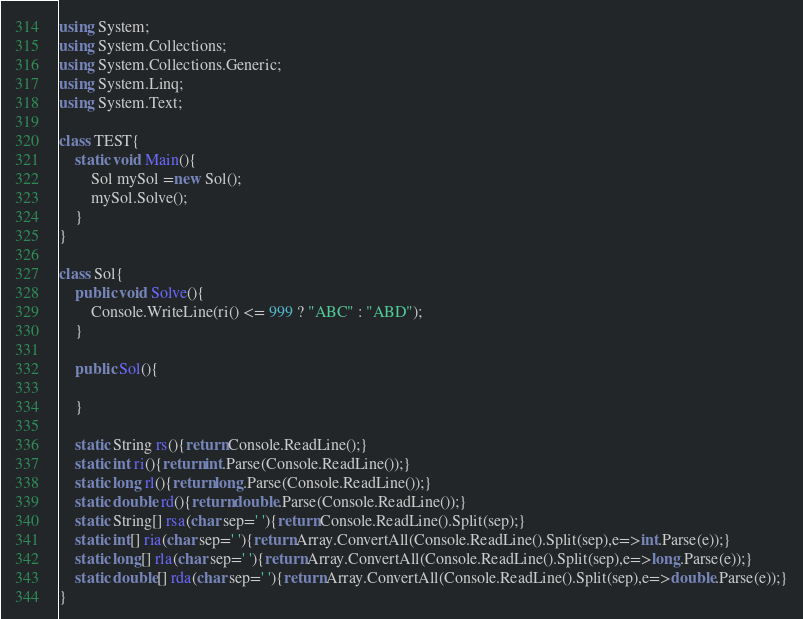Convert code to text. <code><loc_0><loc_0><loc_500><loc_500><_C#_>using System;
using System.Collections;
using System.Collections.Generic;
using System.Linq;
using System.Text;

class TEST{
	static void Main(){
		Sol mySol =new Sol();
		mySol.Solve();
	}
}

class Sol{
	public void Solve(){
		Console.WriteLine(ri() <= 999 ? "ABC" : "ABD");
	}

	public Sol(){
		
	}

	static String rs(){return Console.ReadLine();}
	static int ri(){return int.Parse(Console.ReadLine());}
	static long rl(){return long.Parse(Console.ReadLine());}
	static double rd(){return double.Parse(Console.ReadLine());}
	static String[] rsa(char sep=' '){return Console.ReadLine().Split(sep);}
	static int[] ria(char sep=' '){return Array.ConvertAll(Console.ReadLine().Split(sep),e=>int.Parse(e));}
	static long[] rla(char sep=' '){return Array.ConvertAll(Console.ReadLine().Split(sep),e=>long.Parse(e));}
	static double[] rda(char sep=' '){return Array.ConvertAll(Console.ReadLine().Split(sep),e=>double.Parse(e));}
}
</code> 